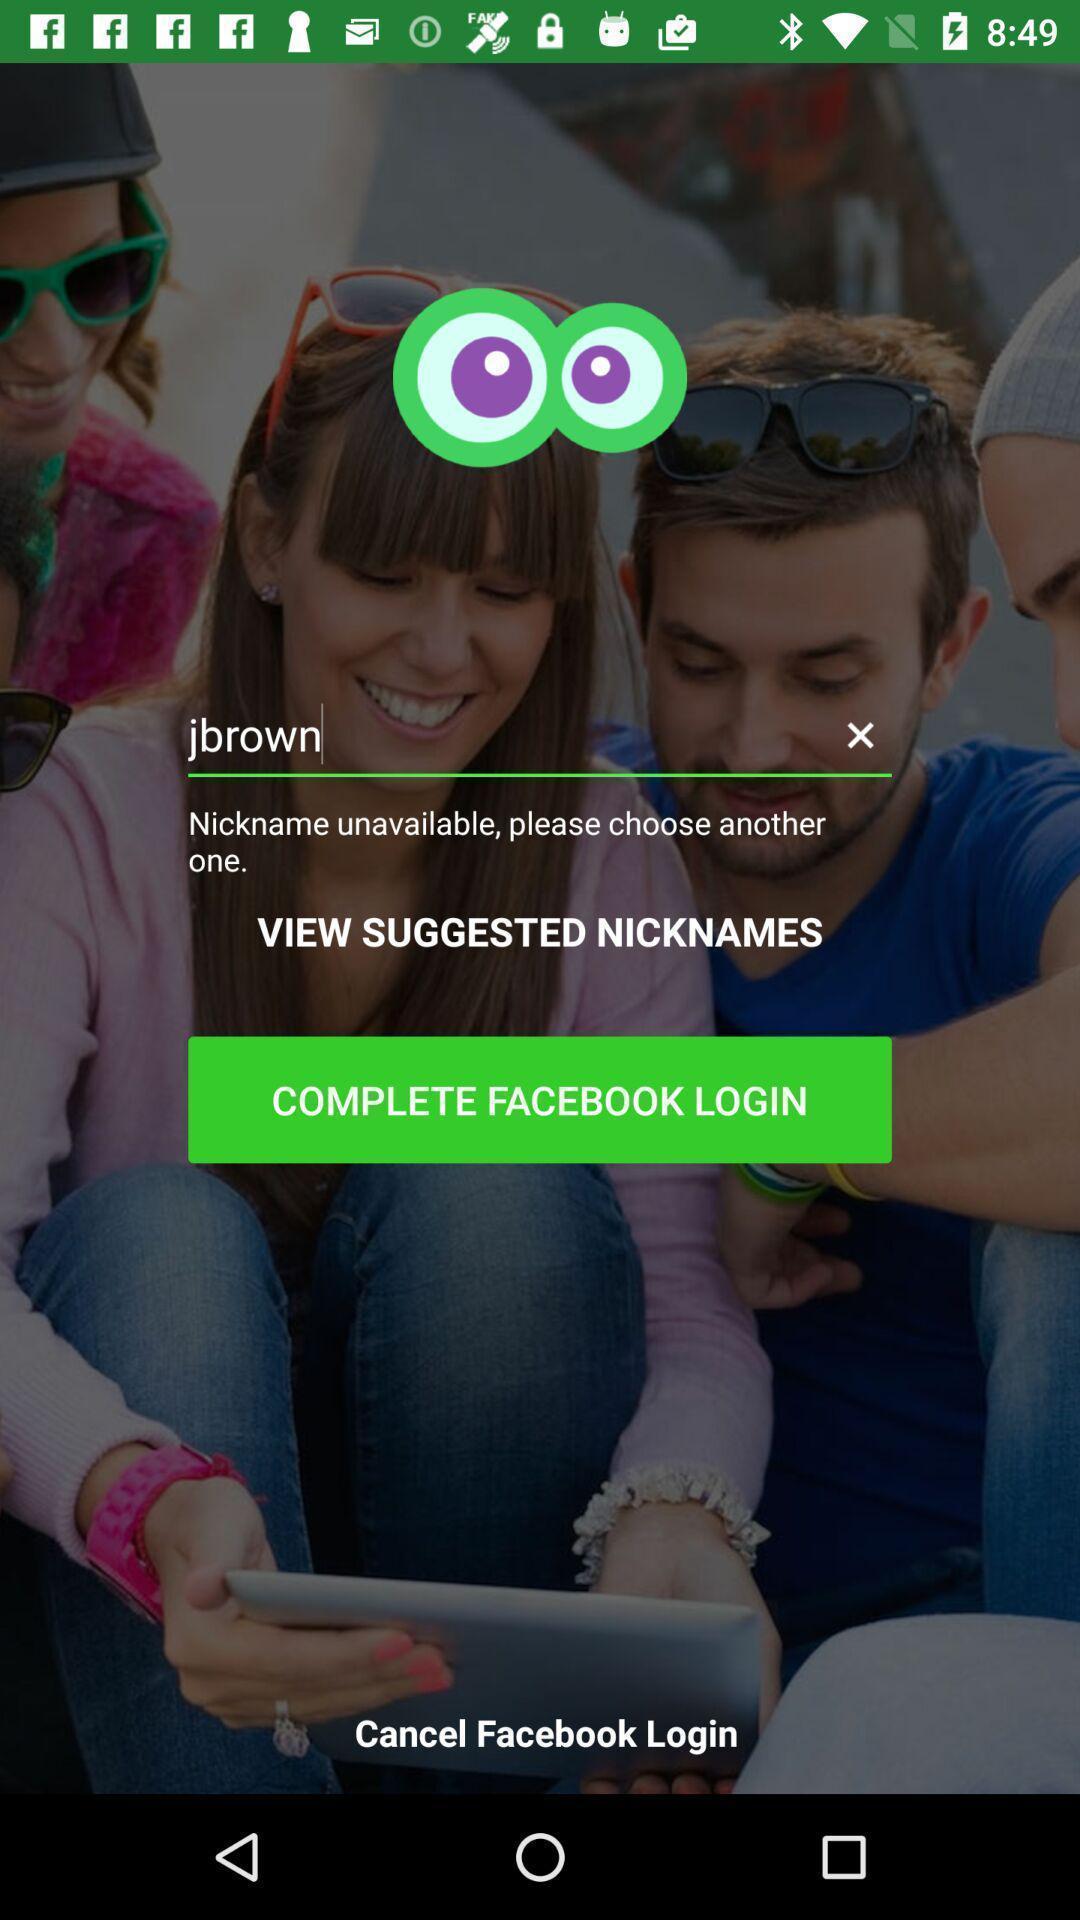Summarize the main components in this picture. Page for setting nickname and login. 